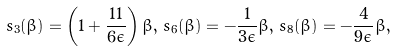<formula> <loc_0><loc_0><loc_500><loc_500>s _ { 3 } ( \beta ) = \left ( 1 + \frac { 1 1 } { 6 \epsilon } \right ) \beta , \, s _ { 6 } ( \beta ) = - \frac { 1 } { 3 \epsilon } \beta , \, s _ { 8 } ( \beta ) = - \frac { 4 } { 9 \epsilon } \beta ,</formula> 